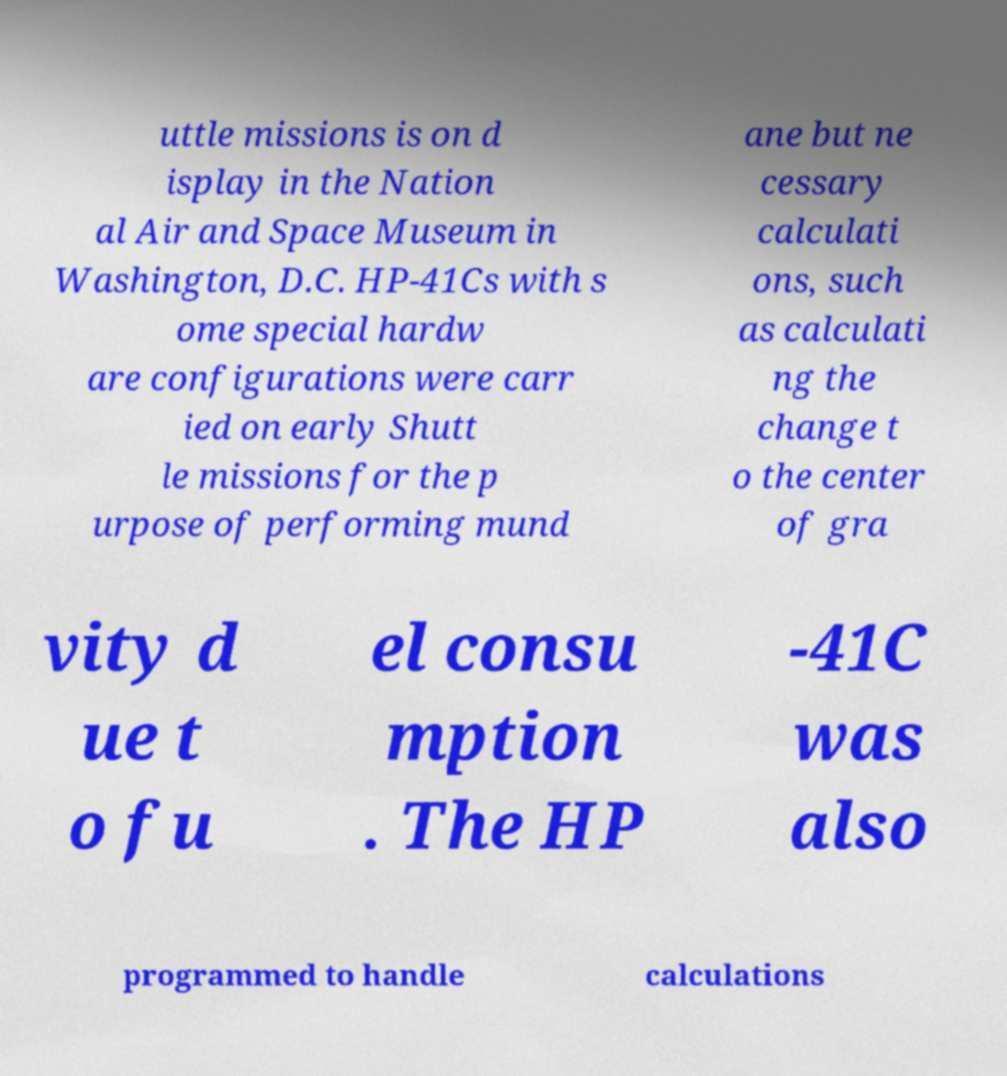There's text embedded in this image that I need extracted. Can you transcribe it verbatim? uttle missions is on d isplay in the Nation al Air and Space Museum in Washington, D.C. HP-41Cs with s ome special hardw are configurations were carr ied on early Shutt le missions for the p urpose of performing mund ane but ne cessary calculati ons, such as calculati ng the change t o the center of gra vity d ue t o fu el consu mption . The HP -41C was also programmed to handle calculations 